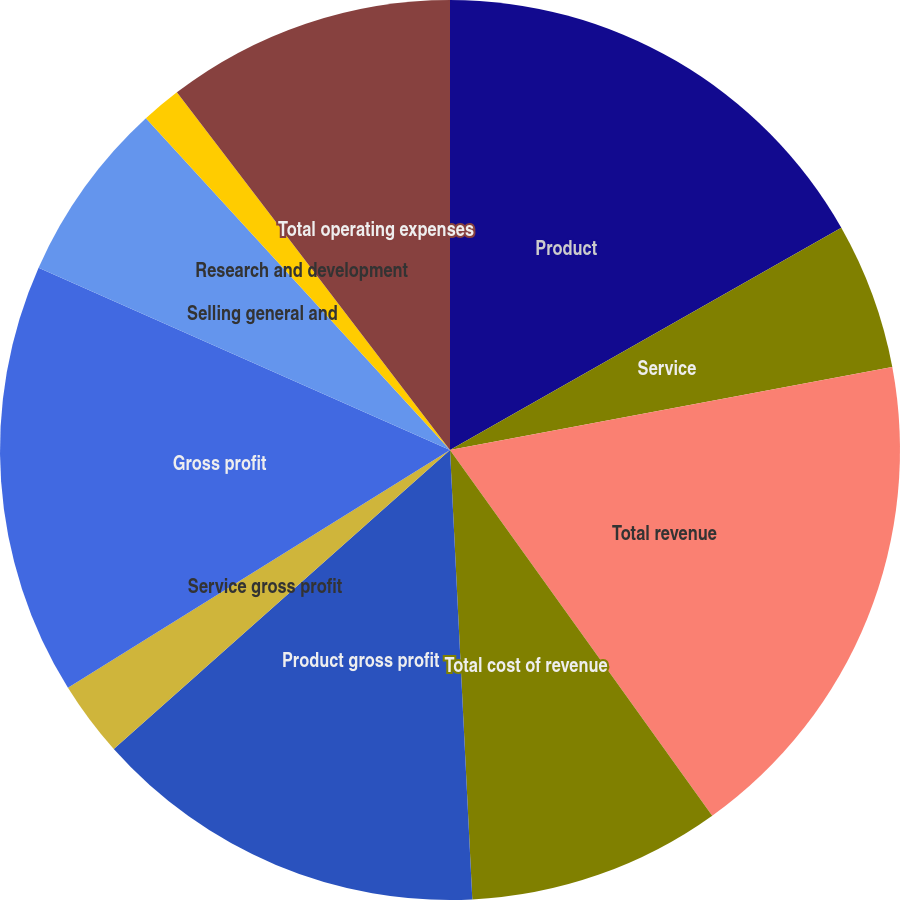Convert chart to OTSL. <chart><loc_0><loc_0><loc_500><loc_500><pie_chart><fcel>Product<fcel>Service<fcel>Total revenue<fcel>Total cost of revenue<fcel>Product gross profit<fcel>Service gross profit<fcel>Gross profit<fcel>Selling general and<fcel>Research and development<fcel>Total operating expenses<nl><fcel>16.78%<fcel>5.27%<fcel>18.05%<fcel>9.11%<fcel>14.22%<fcel>2.71%<fcel>15.5%<fcel>6.55%<fcel>1.43%<fcel>10.38%<nl></chart> 